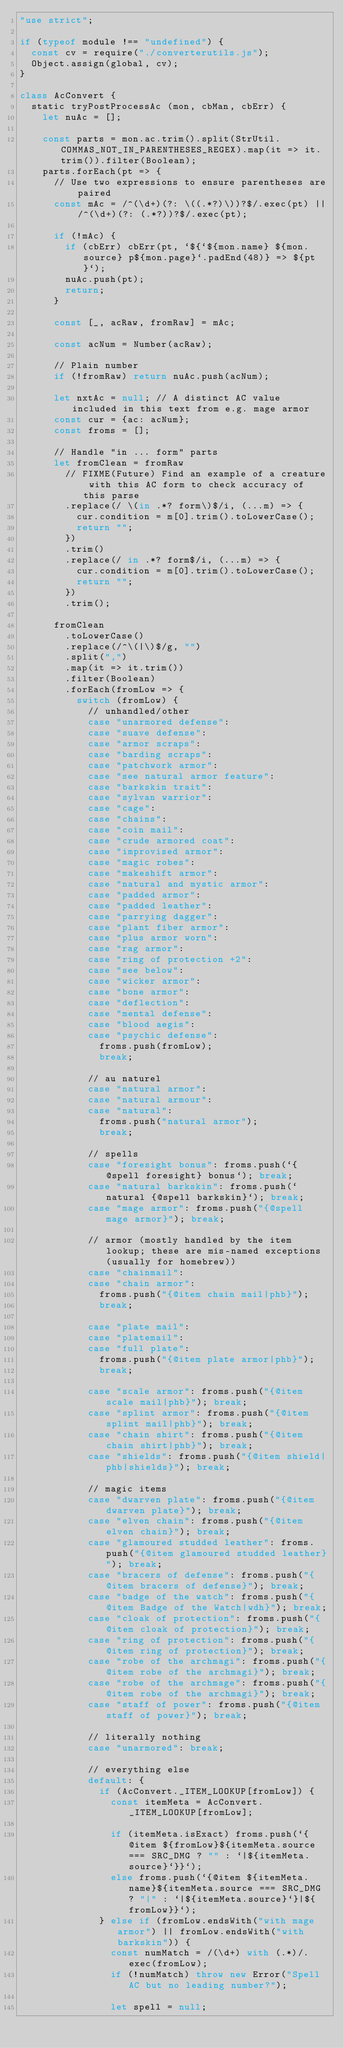Convert code to text. <code><loc_0><loc_0><loc_500><loc_500><_JavaScript_>"use strict";

if (typeof module !== "undefined") {
	const cv = require("./converterutils.js");
	Object.assign(global, cv);
}

class AcConvert {
	static tryPostProcessAc (mon, cbMan, cbErr) {
		let nuAc = [];

		const parts = mon.ac.trim().split(StrUtil.COMMAS_NOT_IN_PARENTHESES_REGEX).map(it => it.trim()).filter(Boolean);
		parts.forEach(pt => {
			// Use two expressions to ensure parentheses are paired
			const mAc = /^(\d+)(?: \((.*?)\))?$/.exec(pt) || /^(\d+)(?: (.*?))?$/.exec(pt);

			if (!mAc) {
				if (cbErr) cbErr(pt, `${`${mon.name} ${mon.source} p${mon.page}`.padEnd(48)} => ${pt}`);
				nuAc.push(pt);
				return;
			}

			const [_, acRaw, fromRaw] = mAc;

			const acNum = Number(acRaw);

			// Plain number
			if (!fromRaw) return nuAc.push(acNum);

			let nxtAc = null; // A distinct AC value included in this text from e.g. mage armor
			const cur = {ac: acNum};
			const froms = [];

			// Handle "in ... form" parts
			let fromClean = fromRaw
				// FIXME(Future) Find an example of a creature with this AC form to check accuracy of this parse
				.replace(/ \(in .*? form\)$/i, (...m) => {
					cur.condition = m[0].trim().toLowerCase();
					return "";
				})
				.trim()
				.replace(/ in .*? form$/i, (...m) => {
					cur.condition = m[0].trim().toLowerCase();
					return "";
				})
				.trim();

			fromClean
				.toLowerCase()
				.replace(/^\(|\)$/g, "")
				.split(",")
				.map(it => it.trim())
				.filter(Boolean)
				.forEach(fromLow => {
					switch (fromLow) {
						// unhandled/other
						case "unarmored defense":
						case "suave defense":
						case "armor scraps":
						case "barding scraps":
						case "patchwork armor":
						case "see natural armor feature":
						case "barkskin trait":
						case "sylvan warrior":
						case "cage":
						case "chains":
						case "coin mail":
						case "crude armored coat":
						case "improvised armor":
						case "magic robes":
						case "makeshift armor":
						case "natural and mystic armor":
						case "padded armor":
						case "padded leather":
						case "parrying dagger":
						case "plant fiber armor":
						case "plus armor worn":
						case "rag armor":
						case "ring of protection +2":
						case "see below":
						case "wicker armor":
						case "bone armor":
						case "deflection":
						case "mental defense":
						case "blood aegis":
						case "psychic defense":
							froms.push(fromLow);
							break;

						// au naturel
						case "natural armor":
						case "natural armour":
						case "natural":
							froms.push("natural armor");
							break;

						// spells
						case "foresight bonus": froms.push(`{@spell foresight} bonus`); break;
						case "natural barkskin": froms.push(`natural {@spell barkskin}`); break;
						case "mage armor": froms.push("{@spell mage armor}"); break;

						// armor (mostly handled by the item lookup; these are mis-named exceptions (usually for homebrew))
						case "chainmail":
						case "chain armor":
							froms.push("{@item chain mail|phb}");
							break;

						case "plate mail":
						case "platemail":
						case "full plate":
							froms.push("{@item plate armor|phb}");
							break;

						case "scale armor": froms.push("{@item scale mail|phb}"); break;
						case "splint armor": froms.push("{@item splint mail|phb}"); break;
						case "chain shirt": froms.push("{@item chain shirt|phb}"); break;
						case "shields": froms.push("{@item shield|phb|shields}"); break;

						// magic items
						case "dwarven plate": froms.push("{@item dwarven plate}"); break;
						case "elven chain": froms.push("{@item elven chain}"); break;
						case "glamoured studded leather": froms.push("{@item glamoured studded leather}"); break;
						case "bracers of defense": froms.push("{@item bracers of defense}"); break;
						case "badge of the watch": froms.push("{@item Badge of the Watch|wdh}"); break;
						case "cloak of protection": froms.push("{@item cloak of protection}"); break;
						case "ring of protection": froms.push("{@item ring of protection}"); break;
						case "robe of the archmagi": froms.push("{@item robe of the archmagi}"); break;
						case "robe of the archmage": froms.push("{@item robe of the archmagi}"); break;
						case "staff of power": froms.push("{@item staff of power}"); break;

						// literally nothing
						case "unarmored": break;

						// everything else
						default: {
							if (AcConvert._ITEM_LOOKUP[fromLow]) {
								const itemMeta = AcConvert._ITEM_LOOKUP[fromLow];

								if (itemMeta.isExact) froms.push(`{@item ${fromLow}${itemMeta.source === SRC_DMG ? "" : `|${itemMeta.source}`}}`);
								else froms.push(`{@item ${itemMeta.name}${itemMeta.source === SRC_DMG ? "|" : `|${itemMeta.source}`}|${fromLow}}`);
							} else if (fromLow.endsWith("with mage armor") || fromLow.endsWith("with barkskin")) {
								const numMatch = /(\d+) with (.*)/.exec(fromLow);
								if (!numMatch) throw new Error("Spell AC but no leading number?");

								let spell = null;</code> 